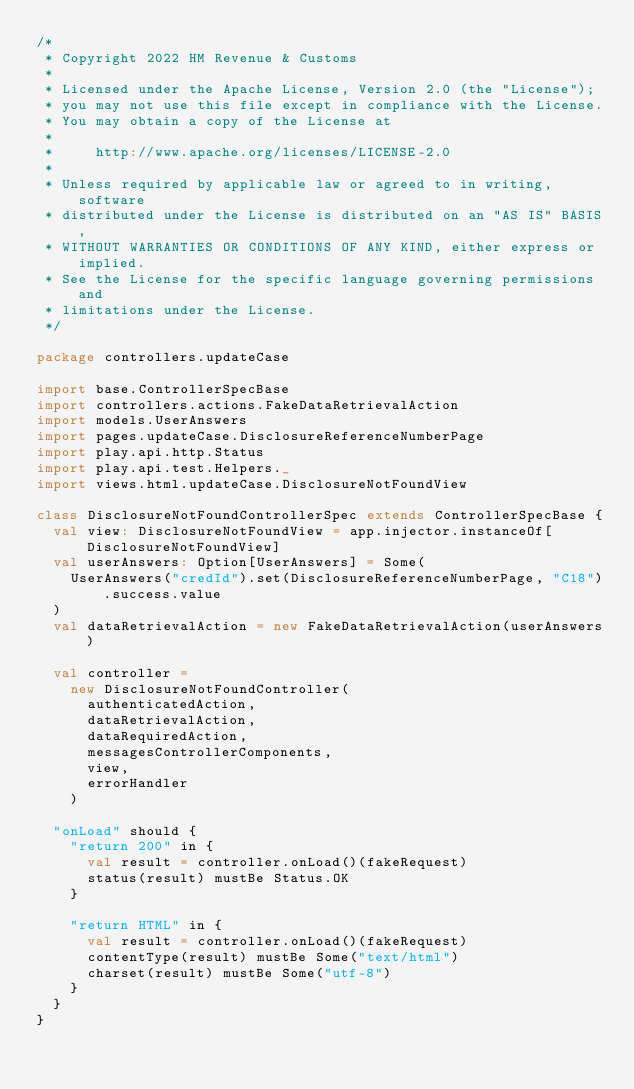Convert code to text. <code><loc_0><loc_0><loc_500><loc_500><_Scala_>/*
 * Copyright 2022 HM Revenue & Customs
 *
 * Licensed under the Apache License, Version 2.0 (the "License");
 * you may not use this file except in compliance with the License.
 * You may obtain a copy of the License at
 *
 *     http://www.apache.org/licenses/LICENSE-2.0
 *
 * Unless required by applicable law or agreed to in writing, software
 * distributed under the License is distributed on an "AS IS" BASIS,
 * WITHOUT WARRANTIES OR CONDITIONS OF ANY KIND, either express or implied.
 * See the License for the specific language governing permissions and
 * limitations under the License.
 */

package controllers.updateCase

import base.ControllerSpecBase
import controllers.actions.FakeDataRetrievalAction
import models.UserAnswers
import pages.updateCase.DisclosureReferenceNumberPage
import play.api.http.Status
import play.api.test.Helpers._
import views.html.updateCase.DisclosureNotFoundView

class DisclosureNotFoundControllerSpec extends ControllerSpecBase {
  val view: DisclosureNotFoundView = app.injector.instanceOf[DisclosureNotFoundView]
  val userAnswers: Option[UserAnswers] = Some(
    UserAnswers("credId").set(DisclosureReferenceNumberPage, "C18").success.value
  )
  val dataRetrievalAction = new FakeDataRetrievalAction(userAnswers)

  val controller =
    new DisclosureNotFoundController(
      authenticatedAction,
      dataRetrievalAction,
      dataRequiredAction,
      messagesControllerComponents,
      view,
      errorHandler
    )

  "onLoad" should {
    "return 200" in {
      val result = controller.onLoad()(fakeRequest)
      status(result) mustBe Status.OK
    }

    "return HTML" in {
      val result = controller.onLoad()(fakeRequest)
      contentType(result) mustBe Some("text/html")
      charset(result) mustBe Some("utf-8")
    }
  }
}
</code> 